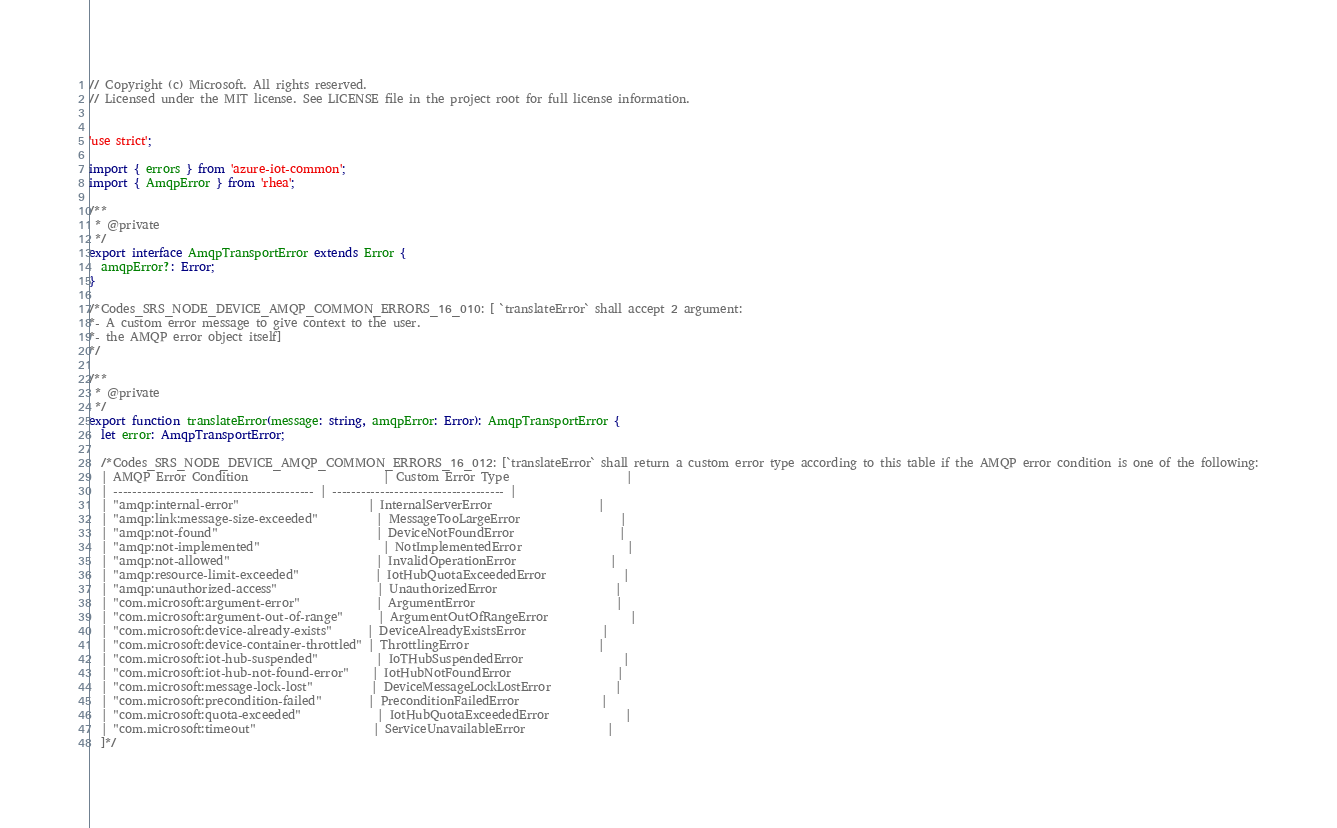Convert code to text. <code><loc_0><loc_0><loc_500><loc_500><_TypeScript_>// Copyright (c) Microsoft. All rights reserved.
// Licensed under the MIT license. See LICENSE file in the project root for full license information.


'use strict';

import { errors } from 'azure-iot-common';
import { AmqpError } from 'rhea';

/**
 * @private
 */
export interface AmqpTransportError extends Error {
  amqpError?: Error;
}

/*Codes_SRS_NODE_DEVICE_AMQP_COMMON_ERRORS_16_010: [ `translateError` shall accept 2 argument:
*- A custom error message to give context to the user.
*- the AMQP error object itself]
*/

/**
 * @private
 */
export function translateError(message: string, amqpError: Error): AmqpTransportError {
  let error: AmqpTransportError;

  /*Codes_SRS_NODE_DEVICE_AMQP_COMMON_ERRORS_16_012: [`translateError` shall return a custom error type according to this table if the AMQP error condition is one of the following:
  | AMQP Error Condition                       | Custom Error Type                    |
  | ------------------------------------------ | ------------------------------------ |
  | "amqp:internal-error"                      | InternalServerError                  |
  | "amqp:link:message-size-exceeded"          | MessageTooLargeError                 |
  | "amqp:not-found"                           | DeviceNotFoundError                  |
  | "amqp:not-implemented"                     | NotImplementedError                  |
  | "amqp:not-allowed"                         | InvalidOperationError                |
  | "amqp:resource-limit-exceeded"             | IotHubQuotaExceededError             |
  | "amqp:unauthorized-access"                 | UnauthorizedError                    |
  | "com.microsoft:argument-error"             | ArgumentError                        |
  | "com.microsoft:argument-out-of-range"      | ArgumentOutOfRangeError              |
  | "com.microsoft:device-already-exists"      | DeviceAlreadyExistsError             |
  | "com.microsoft:device-container-throttled" | ThrottlingError                      |
  | "com.microsoft:iot-hub-suspended"          | IoTHubSuspendedError                 |
  | "com.microsoft:iot-hub-not-found-error"    | IotHubNotFoundError                  |
  | "com.microsoft:message-lock-lost"          | DeviceMessageLockLostError           |
  | "com.microsoft:precondition-failed"        | PreconditionFailedError              |
  | "com.microsoft:quota-exceeded"             | IotHubQuotaExceededError             |
  | "com.microsoft:timeout"                    | ServiceUnavailableError              |
  ]*/
</code> 